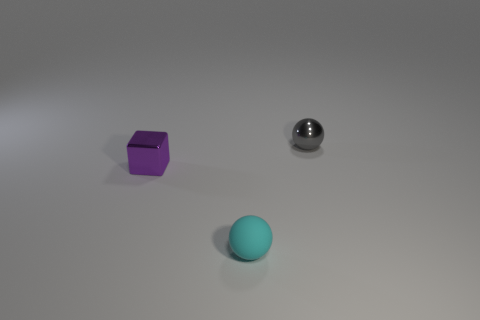Are there any other things that have the same shape as the purple thing?
Your answer should be very brief. No. What number of other things are the same size as the purple metallic thing?
Your answer should be very brief. 2. There is a cyan rubber ball; how many cyan rubber balls are behind it?
Keep it short and to the point. 0. The purple shiny cube has what size?
Provide a succinct answer. Small. Do the thing on the right side of the matte sphere and the tiny ball that is in front of the metal cube have the same material?
Your answer should be compact. No. Are there any tiny matte things of the same color as the metallic sphere?
Keep it short and to the point. No. There is a block that is the same size as the gray metallic sphere; what color is it?
Keep it short and to the point. Purple. Are there any small purple things that have the same material as the gray object?
Your answer should be compact. Yes. Is the number of purple objects that are behind the shiny cube less than the number of tiny purple things?
Give a very brief answer. Yes. There is a metallic object that is behind the purple shiny thing; is its size the same as the tiny matte sphere?
Offer a terse response. Yes. 